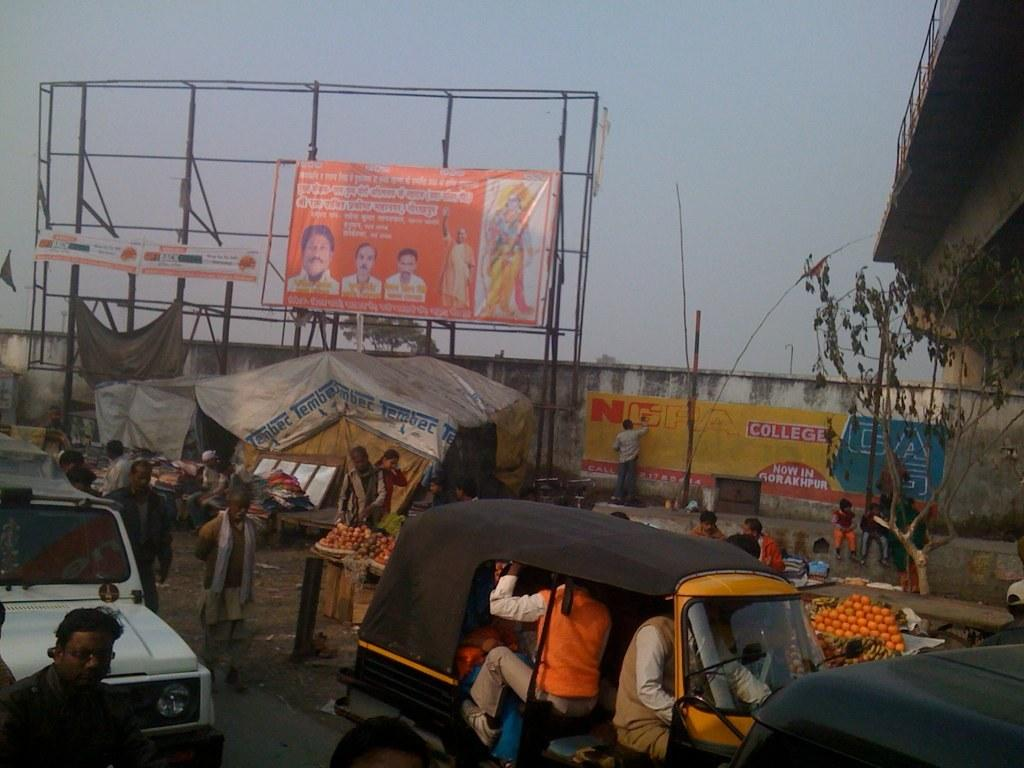<image>
Summarize the visual content of the image. the word college is on a sign next to a road 